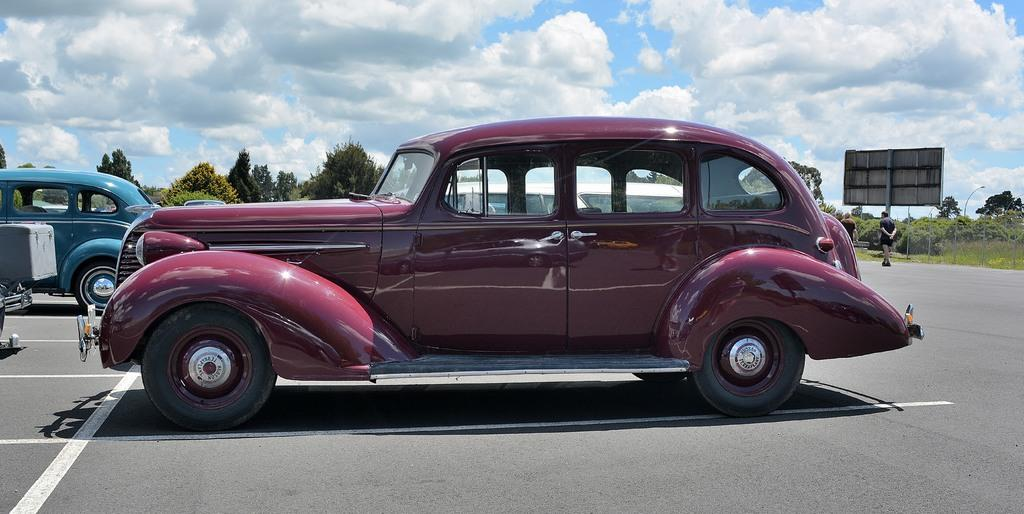What type of vehicles can be seen on the road in the image? There are cars on the road in the image. What are the people in the image doing? There are people walking in the image. What can be seen in the background of the image? In the background, there is a hoarding, lights on poles, grass, plants, trees, and the sky with clouds. Is there snow visible on the ground in the image? No, there is no snow visible in the image; the ground appears to be clear. What act are the trees performing in the image? Trees are not performing any act in the image; they are simply standing in the background. 